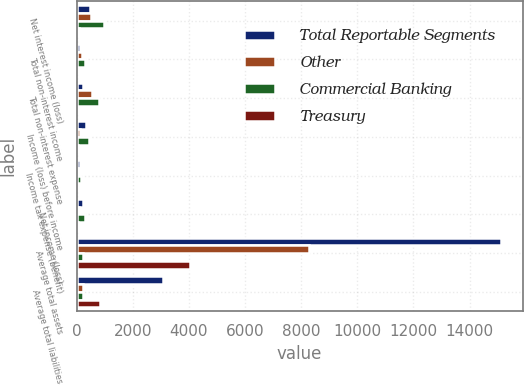Convert chart to OTSL. <chart><loc_0><loc_0><loc_500><loc_500><stacked_bar_chart><ecel><fcel>Net interest income (loss)<fcel>Total non-interest income<fcel>Total non-interest expense<fcel>Income (loss) before income<fcel>Income tax expense (benefit)<fcel>Net income (loss)<fcel>Average total assets<fcel>Average total liabilities<nl><fcel>Total Reportable Segments<fcel>469.3<fcel>123.9<fcel>239<fcel>311.5<fcel>104.6<fcel>206.9<fcel>15131.8<fcel>3083.8<nl><fcel>Other<fcel>504.1<fcel>179.5<fcel>548.7<fcel>121<fcel>40.6<fcel>80.4<fcel>8267.3<fcel>239<nl><fcel>Commercial Banking<fcel>973.4<fcel>303.4<fcel>787.7<fcel>432.5<fcel>145.2<fcel>287.3<fcel>239<fcel>239<nl><fcel>Treasury<fcel>65.8<fcel>7.2<fcel>3.5<fcel>55.1<fcel>18.5<fcel>36.6<fcel>4048.2<fcel>836.3<nl></chart> 